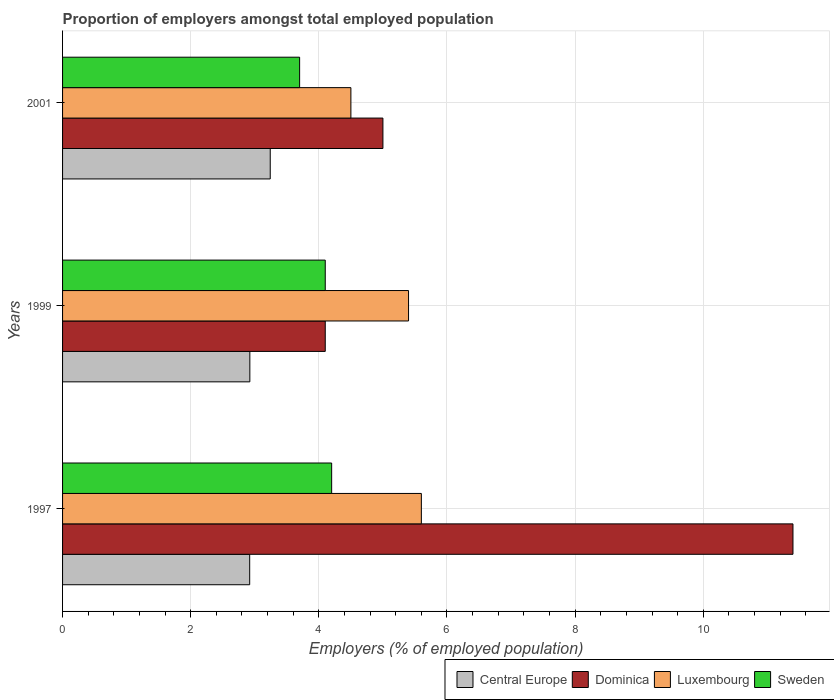Are the number of bars on each tick of the Y-axis equal?
Keep it short and to the point. Yes. In how many cases, is the number of bars for a given year not equal to the number of legend labels?
Give a very brief answer. 0. What is the proportion of employers in Sweden in 1997?
Your answer should be compact. 4.2. Across all years, what is the maximum proportion of employers in Central Europe?
Give a very brief answer. 3.24. Across all years, what is the minimum proportion of employers in Sweden?
Offer a terse response. 3.7. In which year was the proportion of employers in Sweden minimum?
Your answer should be compact. 2001. What is the total proportion of employers in Sweden in the graph?
Provide a succinct answer. 12. What is the difference between the proportion of employers in Dominica in 1997 and that in 1999?
Your answer should be very brief. 7.3. What is the difference between the proportion of employers in Luxembourg in 1997 and the proportion of employers in Dominica in 2001?
Give a very brief answer. 0.6. What is the average proportion of employers in Central Europe per year?
Your answer should be compact. 3.03. In the year 1997, what is the difference between the proportion of employers in Dominica and proportion of employers in Central Europe?
Offer a very short reply. 8.48. What is the ratio of the proportion of employers in Central Europe in 1997 to that in 2001?
Keep it short and to the point. 0.9. Is the proportion of employers in Central Europe in 1997 less than that in 1999?
Your answer should be very brief. Yes. What is the difference between the highest and the second highest proportion of employers in Dominica?
Make the answer very short. 6.4. What is the difference between the highest and the lowest proportion of employers in Sweden?
Provide a succinct answer. 0.5. Is it the case that in every year, the sum of the proportion of employers in Luxembourg and proportion of employers in Dominica is greater than the sum of proportion of employers in Central Europe and proportion of employers in Sweden?
Offer a terse response. Yes. What does the 1st bar from the bottom in 1999 represents?
Offer a very short reply. Central Europe. Is it the case that in every year, the sum of the proportion of employers in Sweden and proportion of employers in Dominica is greater than the proportion of employers in Luxembourg?
Offer a very short reply. Yes. Are all the bars in the graph horizontal?
Ensure brevity in your answer.  Yes. What is the difference between two consecutive major ticks on the X-axis?
Offer a very short reply. 2. Are the values on the major ticks of X-axis written in scientific E-notation?
Ensure brevity in your answer.  No. Does the graph contain grids?
Your answer should be very brief. Yes. How many legend labels are there?
Provide a short and direct response. 4. How are the legend labels stacked?
Your answer should be very brief. Horizontal. What is the title of the graph?
Ensure brevity in your answer.  Proportion of employers amongst total employed population. What is the label or title of the X-axis?
Offer a very short reply. Employers (% of employed population). What is the label or title of the Y-axis?
Your answer should be very brief. Years. What is the Employers (% of employed population) in Central Europe in 1997?
Provide a succinct answer. 2.92. What is the Employers (% of employed population) in Dominica in 1997?
Offer a very short reply. 11.4. What is the Employers (% of employed population) in Luxembourg in 1997?
Offer a very short reply. 5.6. What is the Employers (% of employed population) of Sweden in 1997?
Your answer should be very brief. 4.2. What is the Employers (% of employed population) of Central Europe in 1999?
Provide a succinct answer. 2.92. What is the Employers (% of employed population) of Dominica in 1999?
Keep it short and to the point. 4.1. What is the Employers (% of employed population) of Luxembourg in 1999?
Your answer should be compact. 5.4. What is the Employers (% of employed population) in Sweden in 1999?
Your answer should be very brief. 4.1. What is the Employers (% of employed population) of Central Europe in 2001?
Provide a succinct answer. 3.24. What is the Employers (% of employed population) of Dominica in 2001?
Provide a succinct answer. 5. What is the Employers (% of employed population) in Sweden in 2001?
Keep it short and to the point. 3.7. Across all years, what is the maximum Employers (% of employed population) of Central Europe?
Your answer should be compact. 3.24. Across all years, what is the maximum Employers (% of employed population) in Dominica?
Keep it short and to the point. 11.4. Across all years, what is the maximum Employers (% of employed population) in Luxembourg?
Give a very brief answer. 5.6. Across all years, what is the maximum Employers (% of employed population) in Sweden?
Provide a short and direct response. 4.2. Across all years, what is the minimum Employers (% of employed population) of Central Europe?
Provide a short and direct response. 2.92. Across all years, what is the minimum Employers (% of employed population) of Dominica?
Provide a succinct answer. 4.1. Across all years, what is the minimum Employers (% of employed population) of Sweden?
Your answer should be very brief. 3.7. What is the total Employers (% of employed population) in Central Europe in the graph?
Your answer should be compact. 9.09. What is the total Employers (% of employed population) of Dominica in the graph?
Your answer should be very brief. 20.5. What is the difference between the Employers (% of employed population) in Central Europe in 1997 and that in 1999?
Offer a very short reply. -0. What is the difference between the Employers (% of employed population) in Dominica in 1997 and that in 1999?
Offer a terse response. 7.3. What is the difference between the Employers (% of employed population) in Central Europe in 1997 and that in 2001?
Offer a terse response. -0.32. What is the difference between the Employers (% of employed population) of Dominica in 1997 and that in 2001?
Your response must be concise. 6.4. What is the difference between the Employers (% of employed population) in Sweden in 1997 and that in 2001?
Your answer should be compact. 0.5. What is the difference between the Employers (% of employed population) of Central Europe in 1999 and that in 2001?
Provide a succinct answer. -0.32. What is the difference between the Employers (% of employed population) of Dominica in 1999 and that in 2001?
Provide a succinct answer. -0.9. What is the difference between the Employers (% of employed population) of Central Europe in 1997 and the Employers (% of employed population) of Dominica in 1999?
Offer a terse response. -1.18. What is the difference between the Employers (% of employed population) of Central Europe in 1997 and the Employers (% of employed population) of Luxembourg in 1999?
Provide a short and direct response. -2.48. What is the difference between the Employers (% of employed population) of Central Europe in 1997 and the Employers (% of employed population) of Sweden in 1999?
Provide a short and direct response. -1.18. What is the difference between the Employers (% of employed population) of Luxembourg in 1997 and the Employers (% of employed population) of Sweden in 1999?
Offer a very short reply. 1.5. What is the difference between the Employers (% of employed population) of Central Europe in 1997 and the Employers (% of employed population) of Dominica in 2001?
Provide a succinct answer. -2.08. What is the difference between the Employers (% of employed population) of Central Europe in 1997 and the Employers (% of employed population) of Luxembourg in 2001?
Keep it short and to the point. -1.58. What is the difference between the Employers (% of employed population) in Central Europe in 1997 and the Employers (% of employed population) in Sweden in 2001?
Your response must be concise. -0.78. What is the difference between the Employers (% of employed population) of Dominica in 1997 and the Employers (% of employed population) of Luxembourg in 2001?
Keep it short and to the point. 6.9. What is the difference between the Employers (% of employed population) of Dominica in 1997 and the Employers (% of employed population) of Sweden in 2001?
Your response must be concise. 7.7. What is the difference between the Employers (% of employed population) of Central Europe in 1999 and the Employers (% of employed population) of Dominica in 2001?
Offer a very short reply. -2.08. What is the difference between the Employers (% of employed population) in Central Europe in 1999 and the Employers (% of employed population) in Luxembourg in 2001?
Provide a succinct answer. -1.58. What is the difference between the Employers (% of employed population) in Central Europe in 1999 and the Employers (% of employed population) in Sweden in 2001?
Your response must be concise. -0.78. What is the difference between the Employers (% of employed population) in Dominica in 1999 and the Employers (% of employed population) in Luxembourg in 2001?
Your answer should be compact. -0.4. What is the difference between the Employers (% of employed population) of Dominica in 1999 and the Employers (% of employed population) of Sweden in 2001?
Give a very brief answer. 0.4. What is the average Employers (% of employed population) in Central Europe per year?
Provide a short and direct response. 3.03. What is the average Employers (% of employed population) of Dominica per year?
Keep it short and to the point. 6.83. What is the average Employers (% of employed population) of Luxembourg per year?
Offer a very short reply. 5.17. In the year 1997, what is the difference between the Employers (% of employed population) in Central Europe and Employers (% of employed population) in Dominica?
Keep it short and to the point. -8.48. In the year 1997, what is the difference between the Employers (% of employed population) of Central Europe and Employers (% of employed population) of Luxembourg?
Keep it short and to the point. -2.68. In the year 1997, what is the difference between the Employers (% of employed population) of Central Europe and Employers (% of employed population) of Sweden?
Offer a very short reply. -1.28. In the year 1997, what is the difference between the Employers (% of employed population) in Luxembourg and Employers (% of employed population) in Sweden?
Provide a succinct answer. 1.4. In the year 1999, what is the difference between the Employers (% of employed population) in Central Europe and Employers (% of employed population) in Dominica?
Your response must be concise. -1.18. In the year 1999, what is the difference between the Employers (% of employed population) in Central Europe and Employers (% of employed population) in Luxembourg?
Give a very brief answer. -2.48. In the year 1999, what is the difference between the Employers (% of employed population) of Central Europe and Employers (% of employed population) of Sweden?
Give a very brief answer. -1.18. In the year 2001, what is the difference between the Employers (% of employed population) in Central Europe and Employers (% of employed population) in Dominica?
Keep it short and to the point. -1.76. In the year 2001, what is the difference between the Employers (% of employed population) of Central Europe and Employers (% of employed population) of Luxembourg?
Ensure brevity in your answer.  -1.26. In the year 2001, what is the difference between the Employers (% of employed population) in Central Europe and Employers (% of employed population) in Sweden?
Make the answer very short. -0.46. In the year 2001, what is the difference between the Employers (% of employed population) of Dominica and Employers (% of employed population) of Luxembourg?
Keep it short and to the point. 0.5. In the year 2001, what is the difference between the Employers (% of employed population) of Dominica and Employers (% of employed population) of Sweden?
Make the answer very short. 1.3. What is the ratio of the Employers (% of employed population) in Central Europe in 1997 to that in 1999?
Your answer should be compact. 1. What is the ratio of the Employers (% of employed population) of Dominica in 1997 to that in 1999?
Offer a very short reply. 2.78. What is the ratio of the Employers (% of employed population) in Sweden in 1997 to that in 1999?
Your response must be concise. 1.02. What is the ratio of the Employers (% of employed population) in Central Europe in 1997 to that in 2001?
Give a very brief answer. 0.9. What is the ratio of the Employers (% of employed population) of Dominica in 1997 to that in 2001?
Provide a short and direct response. 2.28. What is the ratio of the Employers (% of employed population) in Luxembourg in 1997 to that in 2001?
Offer a terse response. 1.24. What is the ratio of the Employers (% of employed population) of Sweden in 1997 to that in 2001?
Your answer should be compact. 1.14. What is the ratio of the Employers (% of employed population) in Central Europe in 1999 to that in 2001?
Ensure brevity in your answer.  0.9. What is the ratio of the Employers (% of employed population) of Dominica in 1999 to that in 2001?
Your answer should be very brief. 0.82. What is the ratio of the Employers (% of employed population) of Sweden in 1999 to that in 2001?
Your answer should be compact. 1.11. What is the difference between the highest and the second highest Employers (% of employed population) of Central Europe?
Ensure brevity in your answer.  0.32. What is the difference between the highest and the second highest Employers (% of employed population) of Dominica?
Provide a succinct answer. 6.4. What is the difference between the highest and the second highest Employers (% of employed population) in Sweden?
Provide a succinct answer. 0.1. What is the difference between the highest and the lowest Employers (% of employed population) of Central Europe?
Make the answer very short. 0.32. What is the difference between the highest and the lowest Employers (% of employed population) in Dominica?
Provide a succinct answer. 7.3. 